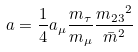Convert formula to latex. <formula><loc_0><loc_0><loc_500><loc_500>a = \frac { 1 } { 4 } a _ { \mu } \frac { m _ { \tau } } { m _ { \mu } } \frac { { m _ { 2 3 } } ^ { 2 } } { { \bar { m } } ^ { 2 } }</formula> 